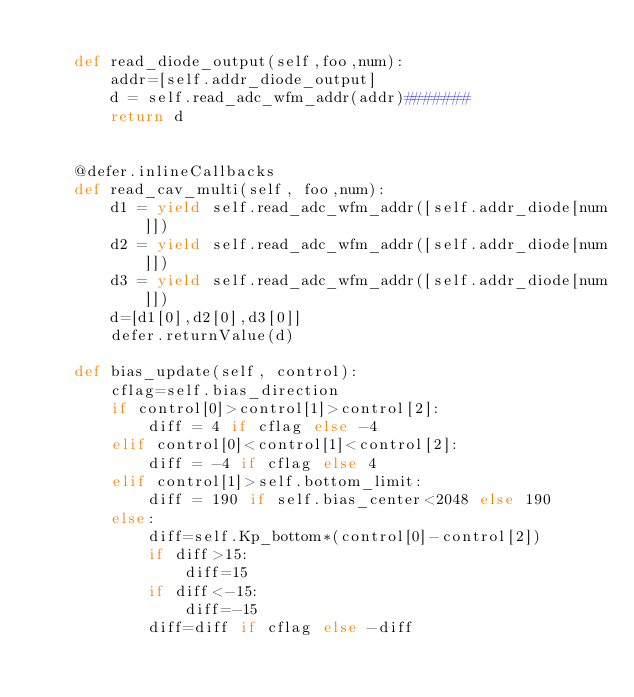Convert code to text. <code><loc_0><loc_0><loc_500><loc_500><_Python_>
    def read_diode_output(self,foo,num):
        addr=[self.addr_diode_output]
        d = self.read_adc_wfm_addr(addr)#######
        return d


    @defer.inlineCallbacks
    def read_cav_multi(self, foo,num):
        d1 = yield self.read_adc_wfm_addr([self.addr_diode[num]])
        d2 = yield self.read_adc_wfm_addr([self.addr_diode[num]])
        d3 = yield self.read_adc_wfm_addr([self.addr_diode[num]])
        d=[d1[0],d2[0],d3[0]]
        defer.returnValue(d)

    def bias_update(self, control):
        cflag=self.bias_direction
        if control[0]>control[1]>control[2]:
            diff = 4 if cflag else -4
        elif control[0]<control[1]<control[2]:
            diff = -4 if cflag else 4
        elif control[1]>self.bottom_limit:
            diff = 190 if self.bias_center<2048 else 190
        else:
            diff=self.Kp_bottom*(control[0]-control[2])
            if diff>15:
                diff=15
            if diff<-15:
                diff=-15
            diff=diff if cflag else -diff</code> 